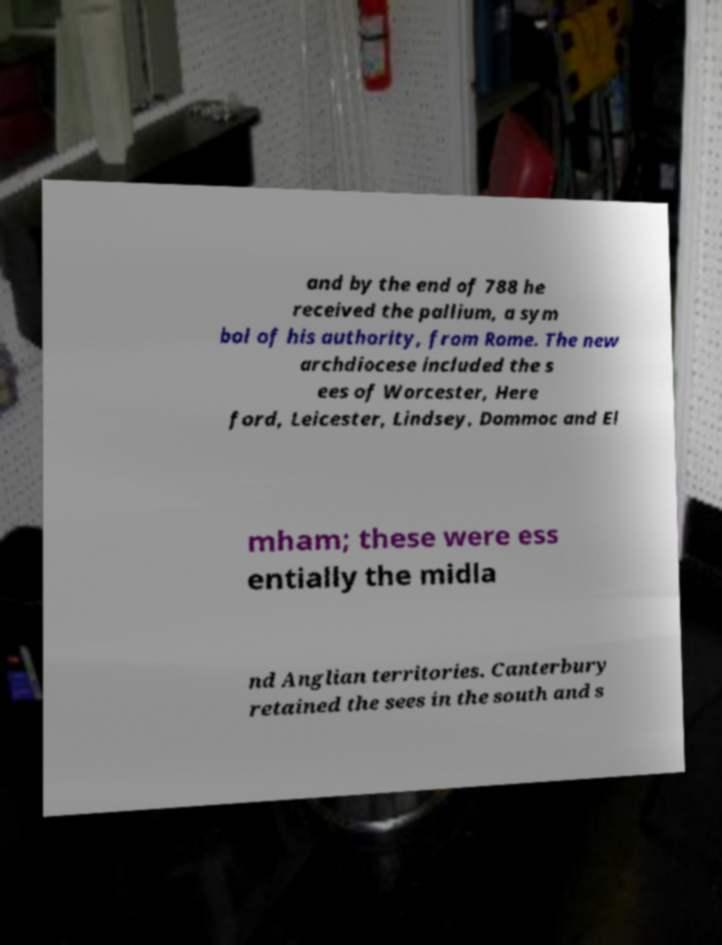Could you extract and type out the text from this image? and by the end of 788 he received the pallium, a sym bol of his authority, from Rome. The new archdiocese included the s ees of Worcester, Here ford, Leicester, Lindsey, Dommoc and El mham; these were ess entially the midla nd Anglian territories. Canterbury retained the sees in the south and s 